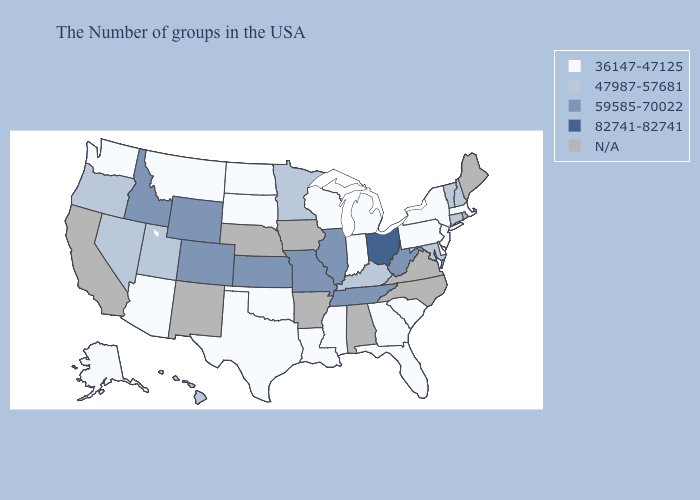What is the value of Illinois?
Be succinct. 59585-70022. Among the states that border Maryland , does Pennsylvania have the lowest value?
Keep it brief. Yes. Among the states that border Vermont , which have the highest value?
Answer briefly. New Hampshire. Among the states that border Idaho , does Wyoming have the highest value?
Concise answer only. Yes. What is the value of Nevada?
Keep it brief. 47987-57681. Name the states that have a value in the range N/A?
Answer briefly. Maine, Rhode Island, Virginia, North Carolina, Alabama, Arkansas, Iowa, Nebraska, New Mexico, California. Does New Jersey have the lowest value in the USA?
Quick response, please. Yes. Name the states that have a value in the range N/A?
Quick response, please. Maine, Rhode Island, Virginia, North Carolina, Alabama, Arkansas, Iowa, Nebraska, New Mexico, California. Name the states that have a value in the range 36147-47125?
Concise answer only. Massachusetts, New York, New Jersey, Delaware, Pennsylvania, South Carolina, Florida, Georgia, Michigan, Indiana, Wisconsin, Mississippi, Louisiana, Oklahoma, Texas, South Dakota, North Dakota, Montana, Arizona, Washington, Alaska. What is the value of Georgia?
Write a very short answer. 36147-47125. Name the states that have a value in the range N/A?
Give a very brief answer. Maine, Rhode Island, Virginia, North Carolina, Alabama, Arkansas, Iowa, Nebraska, New Mexico, California. Which states have the lowest value in the West?
Short answer required. Montana, Arizona, Washington, Alaska. Does Tennessee have the lowest value in the USA?
Concise answer only. No. Among the states that border New Mexico , which have the lowest value?
Give a very brief answer. Oklahoma, Texas, Arizona. 